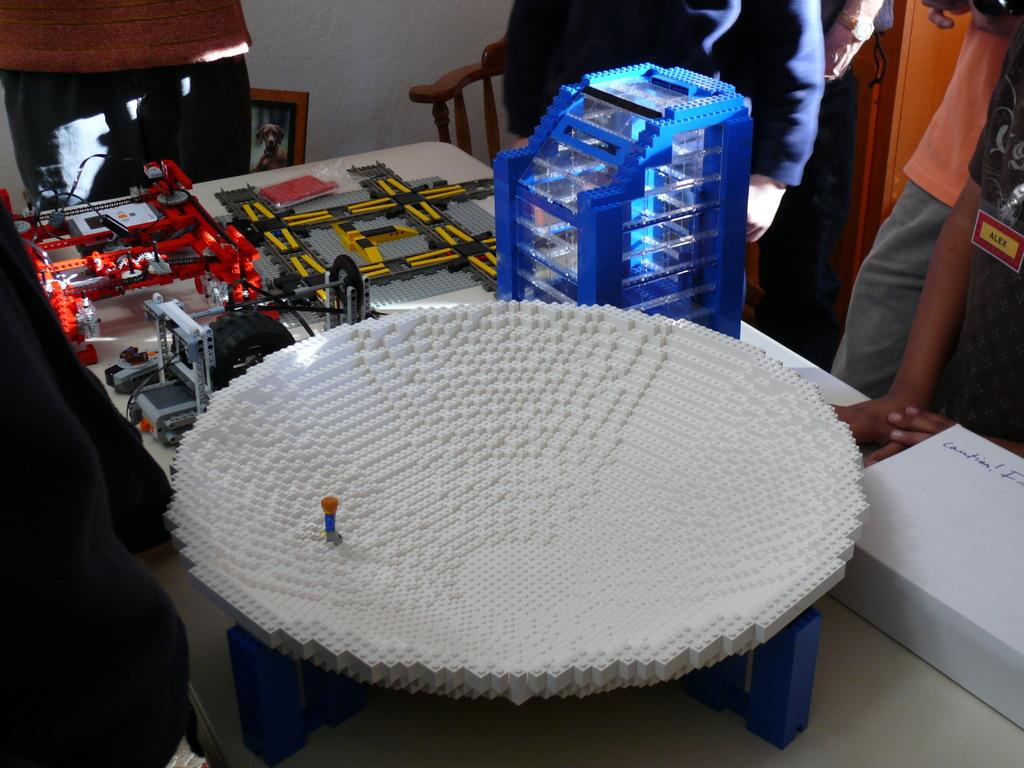What is the main subject of the image? The main subject of the image is crafts made with lego bricks. Where are the lego crafts located in the image? The lego crafts are in the center of the image. What furniture is present in the image? There is a table and a chair in the image. Can you describe the people in the background of the image? There are people standing around the table in the background of the image. What type of fiction is the donkey reading in the image? A: There is no donkey or any reading material present in the image. 